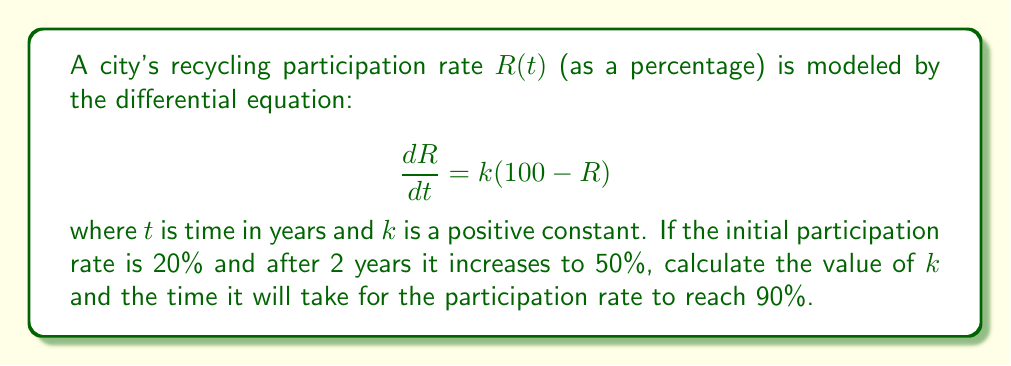Show me your answer to this math problem. 1) First, we need to solve the differential equation:
   $$\frac{dR}{dt} = k(100 - R)$$
   This is a separable equation. Rearranging:
   $$\frac{dR}{100 - R} = k dt$$

2) Integrating both sides:
   $$\int \frac{dR}{100 - R} = \int k dt$$
   $$-\ln|100 - R| = kt + C$$

3) Solving for $R$:
   $$R = 100 - Ce^{-kt}$$
   where $C$ is a constant of integration.

4) Using the initial condition $R(0) = 20$:
   $$20 = 100 - C$$
   $$C = 80$$

5) So our solution is:
   $$R = 100 - 80e^{-kt}$$

6) Now, we use the condition that $R(2) = 50$:
   $$50 = 100 - 80e^{-2k}$$
   $$80e^{-2k} = 50$$
   $$e^{-2k} = \frac{5}{8}$$
   $$-2k = \ln(\frac{5}{8})$$
   $$k = -\frac{1}{2}\ln(\frac{5}{8}) \approx 0.2231$$

7) To find when $R = 90$, we solve:
   $$90 = 100 - 80e^{-kt}$$
   $$10 = 80e^{-kt}$$
   $$\frac{1}{8} = e^{-kt}$$
   $$-kt = \ln(\frac{1}{8})$$
   $$t = -\frac{\ln(\frac{1}{8})}{k} \approx 9.3891$$
Answer: $k \approx 0.2231$, $t \approx 9.3891$ years 